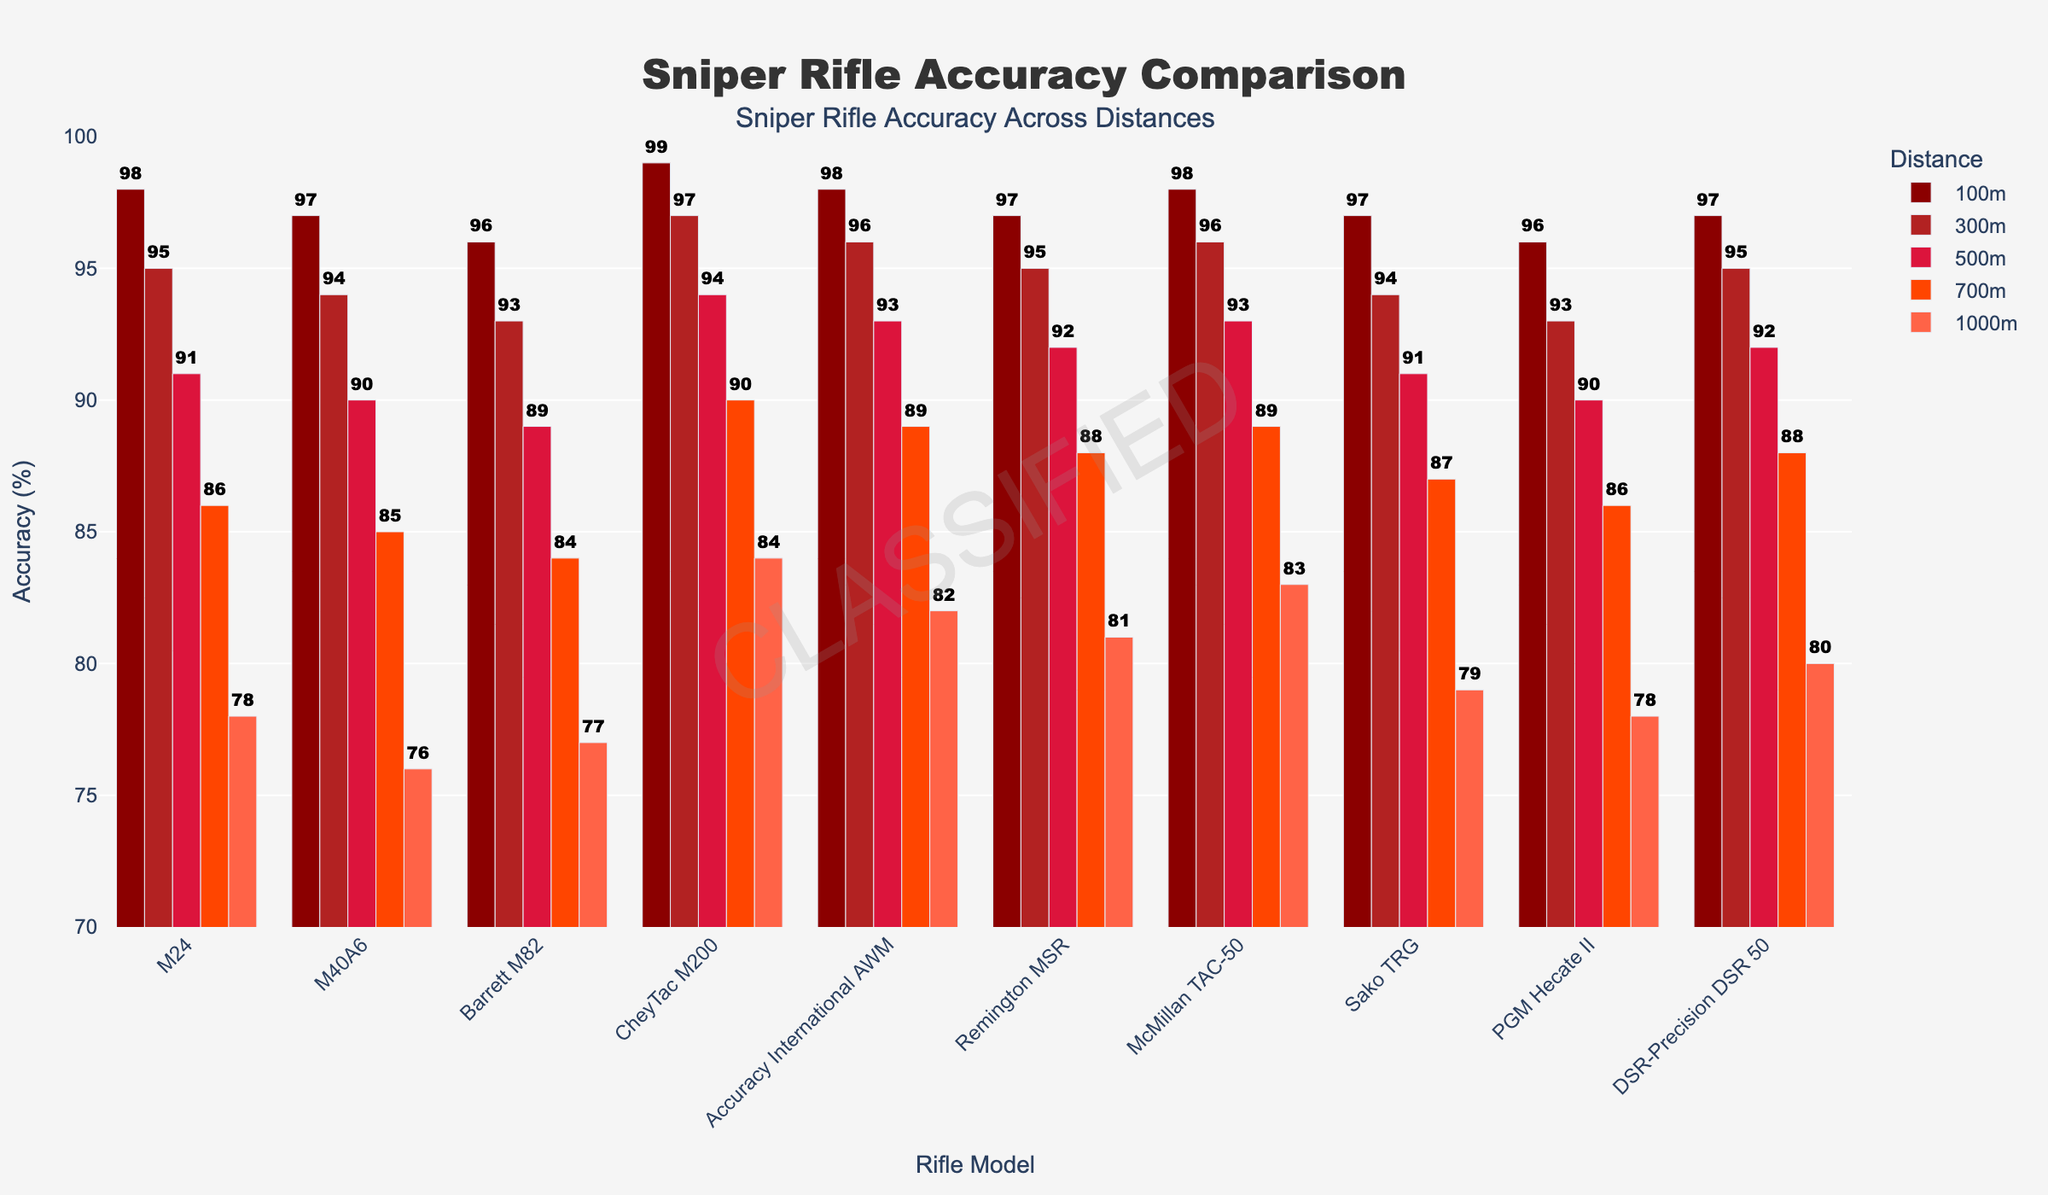What sniper rifle model has the highest accuracy at 1000m? Look at the bars indicating the accuracy at 1000m. CheyTac M200 has the highest value (84%).
Answer: CheyTac M200 Which sniper rifle models have the same accuracy at 300m? Identify the bars for the 300m distance and check for equal heights. Both the M24 and Remington MSR have an accuracy rate of 95%.
Answer: M24, Remington MSR Which distance shows the most consistent accuracy rates across all models? Look for the distance where the bars are closest in height across all models. The 100m distance has the most consistent accuracy rates, ranging between 96% and 99%.
Answer: 100m What is the average accuracy of the McMillan TAC-50 sniper rifle across all distances? Add the accuracy rates for the McMillan TAC-50 at all distances: (98 + 96 + 93 + 89 + 83) = 459. Then divide by the number of distances (5). 459 / 5 = 91.8
Answer: 91.8 Which sniper rifle model shows the largest drop in accuracy from 100m to 1000m? Compute the difference between the 100m and 1000m accuracy for each model and find the largest: CheyTac M200 (99 - 84 = 15), Remington MSR (97 - 81 = 16), Sako TRG (97 - 79 = 18), and so forth. Sako TRG has the largest drop (18%).
Answer: Sako TRG Between distances 300m and 500m, which rifle model shows the smallest drop in accuracy? Compute the difference for each model between 300m and 500m and identify the smallest value: M24 (95 - 91 = 4), M40A6 (94 - 90 = 4), Barrett M82 (93 - 89 = 4), CheyTac M200 (97 - 94 = 3), and so forth. CheyTac M200 shows the smallest drop (3%).
Answer: CheyTac M200 Compare the accuracy rates of the Barrett M82 and the DSR-Precision DSR 50 at a distance of 700m. Which is more accurate? Look at the bars for the Barrett M82 and DSR-Precision DSR 50 at 700m: Barrett M82 (84%), DSR-Precision DSR 50 (88%). DSR-Precision DSR 50 is more accurate.
Answer: DSR-Precision DSR 50 What is the overall trend in accuracy as the distance increases from 100m to 1000m? Notice how the heights of the bars generally decrease as distance increases, indicating accuracy drops as distance increases.
Answer: Accuracy decreases By how much does the Accuracy International AWM’s accuracy decrease from 100m to 700m? Subtract the 700m accuracy from the 100m accuracy for Accuracy International AWM: 98 - 89 = 9.
Answer: 9 What is the median accuracy rate of the Sako TRG at all distances? List the accuracy rates of the Sako TRG (97, 94, 91, 87, 79) and find the middle value: 91.
Answer: 91 